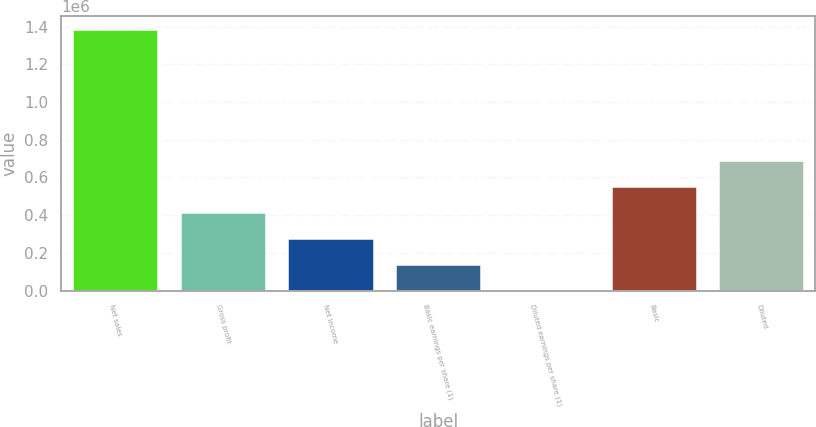Convert chart to OTSL. <chart><loc_0><loc_0><loc_500><loc_500><bar_chart><fcel>Net sales<fcel>Gross profit<fcel>Net income<fcel>Basic earnings per share (1)<fcel>Diluted earnings per share (1)<fcel>Basic<fcel>Diluted<nl><fcel>1.38734e+06<fcel>416202<fcel>277468<fcel>138734<fcel>0.18<fcel>554936<fcel>693671<nl></chart> 